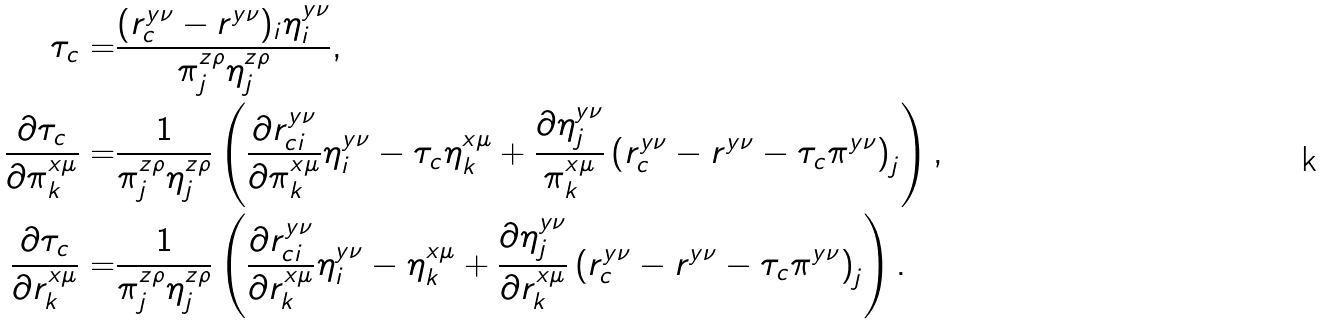<formula> <loc_0><loc_0><loc_500><loc_500>\tau _ { c } = & \frac { ( r _ { c } ^ { y \nu } - r ^ { y \nu } ) _ { i } \eta ^ { y \nu } _ { i } } { \pi ^ { z \rho } _ { j } \eta ^ { z \rho } _ { j } } , \\ \frac { \partial { \tau _ { c } } } { \partial \pi ^ { x \mu } _ { k } } = & \frac { 1 } { \pi _ { j } ^ { z \rho } \eta _ { j } ^ { z \rho } } \left ( \frac { \partial r ^ { y \nu } _ { c i } } { \partial \pi ^ { x \mu } _ { k } } \eta ^ { y \nu } _ { i } - \tau _ { c } \eta ^ { x \mu } _ { k } + \frac { \partial { \eta _ { j } ^ { y \nu } } } { \pi ^ { x \mu } _ { k } } \left ( r _ { c } ^ { y \nu } - r ^ { y \nu } - \tau _ { c } \pi ^ { y \nu } \right ) _ { j } \right ) , \\ \frac { \partial { \tau _ { c } } } { \partial r ^ { x \mu } _ { k } } = & \frac { 1 } { \pi _ { j } ^ { z \rho } \eta _ { j } ^ { z \rho } } \left ( \frac { \partial r ^ { y \nu } _ { c i } } { \partial r ^ { x \mu } _ { k } } \eta ^ { y \nu } _ { i } - \eta ^ { x \mu } _ { k } + \frac { \partial { \eta ^ { y \nu } _ { j } } } { \partial r ^ { x \mu } _ { k } } \left ( r ^ { y \nu } _ { c } - r ^ { y \nu } - \tau _ { c } \pi ^ { y \nu } \right ) _ { j } \right ) .</formula> 